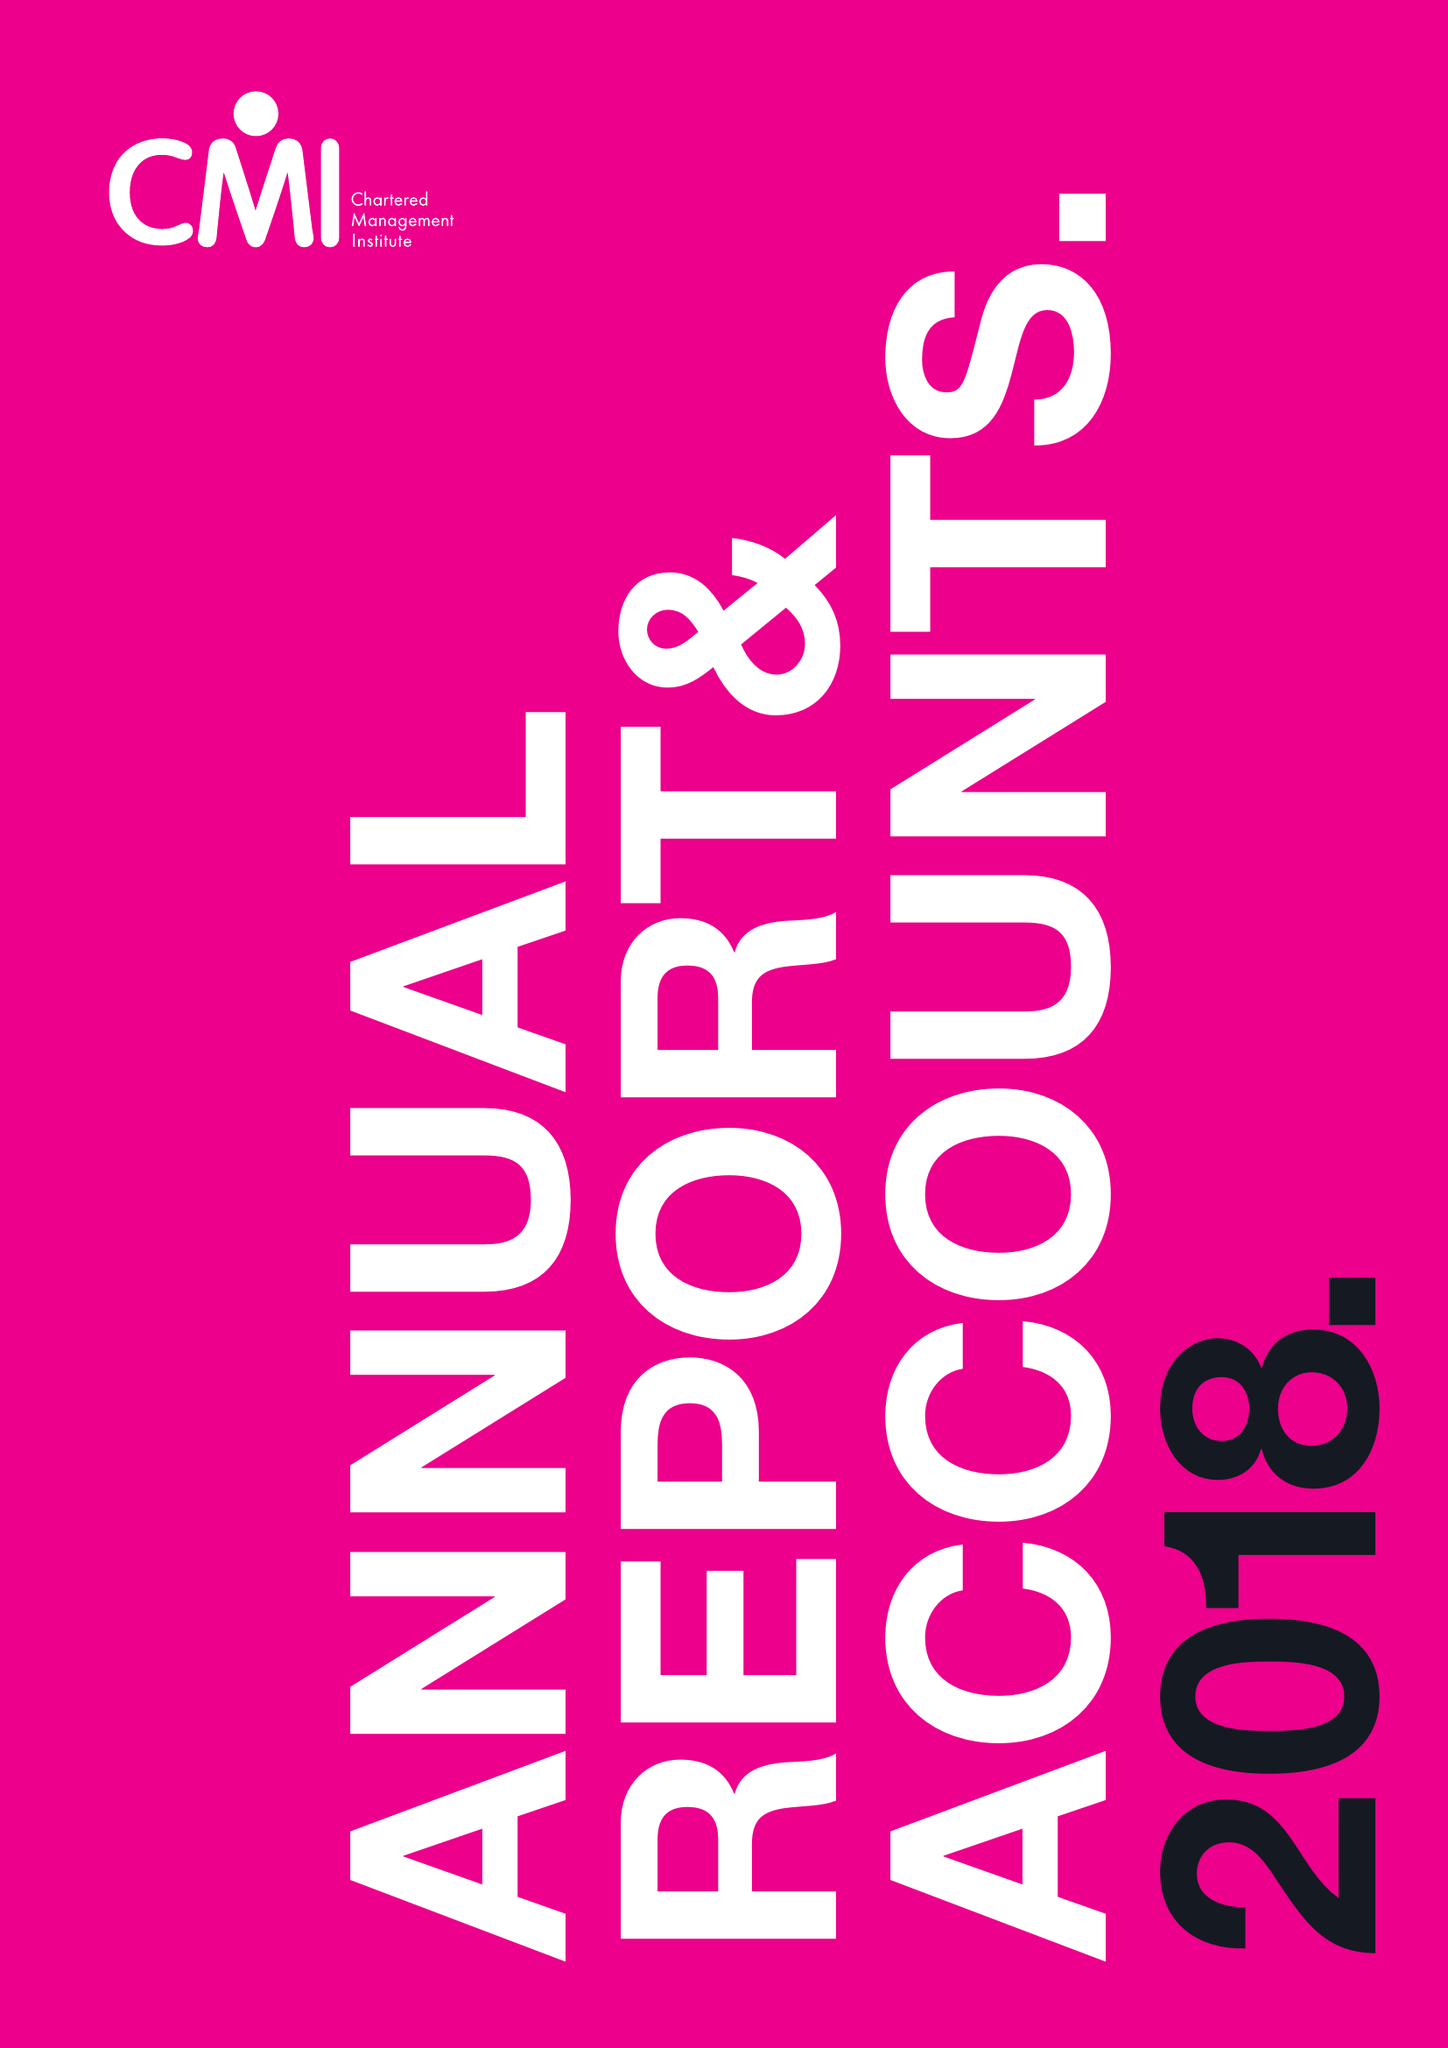What is the value for the charity_number?
Answer the question using a single word or phrase. 1091035 